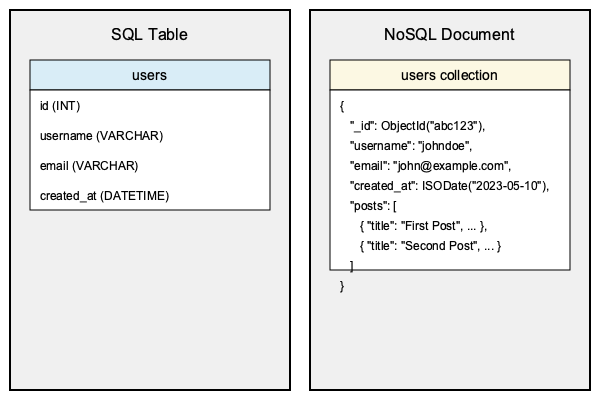Based on the visual comparison between SQL table structure and NoSQL document structure, which of the following statements is true? Let's analyze the differences between the SQL table structure and NoSQL document structure:

1. Data Model:
   - SQL: The data is organized in a table called "users" with predefined columns.
   - NoSQL: The data is stored in a "users collection" as flexible documents.

2. Schema:
   - SQL: The table has a fixed schema with defined data types (e.g., INT, VARCHAR, DATETIME).
   - NoSQL: The document has a flexible schema without strict data type definitions.

3. Relationships:
   - SQL: Relationships between tables are typically handled through foreign keys (not shown in this example).
   - NoSQL: Related data can be embedded within the document (e.g., the "posts" array in the user document).

4. Identification:
   - SQL: Uses a numeric "id" field as the primary key.
   - NoSQL: Uses a special "_id" field with an ObjectId as the unique identifier.

5. Nesting:
   - SQL: Data is flat, with each field represented as a column.
   - NoSQL: Data can be nested, allowing for more complex structures (e.g., the "posts" array).

6. Flexibility:
   - SQL: Adding new fields requires altering the table structure.
   - NoSQL: New fields can be added to individual documents without affecting others.

Based on these observations, the most significant difference is the ability of NoSQL to handle nested and flexible data structures within a single document, which is not possible in the SQL table structure shown.
Answer: NoSQL allows nested data structures within a single document. 